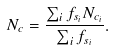Convert formula to latex. <formula><loc_0><loc_0><loc_500><loc_500>N _ { c } = \frac { \sum _ { i } f _ { s _ { i } } N _ { c _ { i } } } { \sum _ { i } f _ { s _ { i } } } .</formula> 